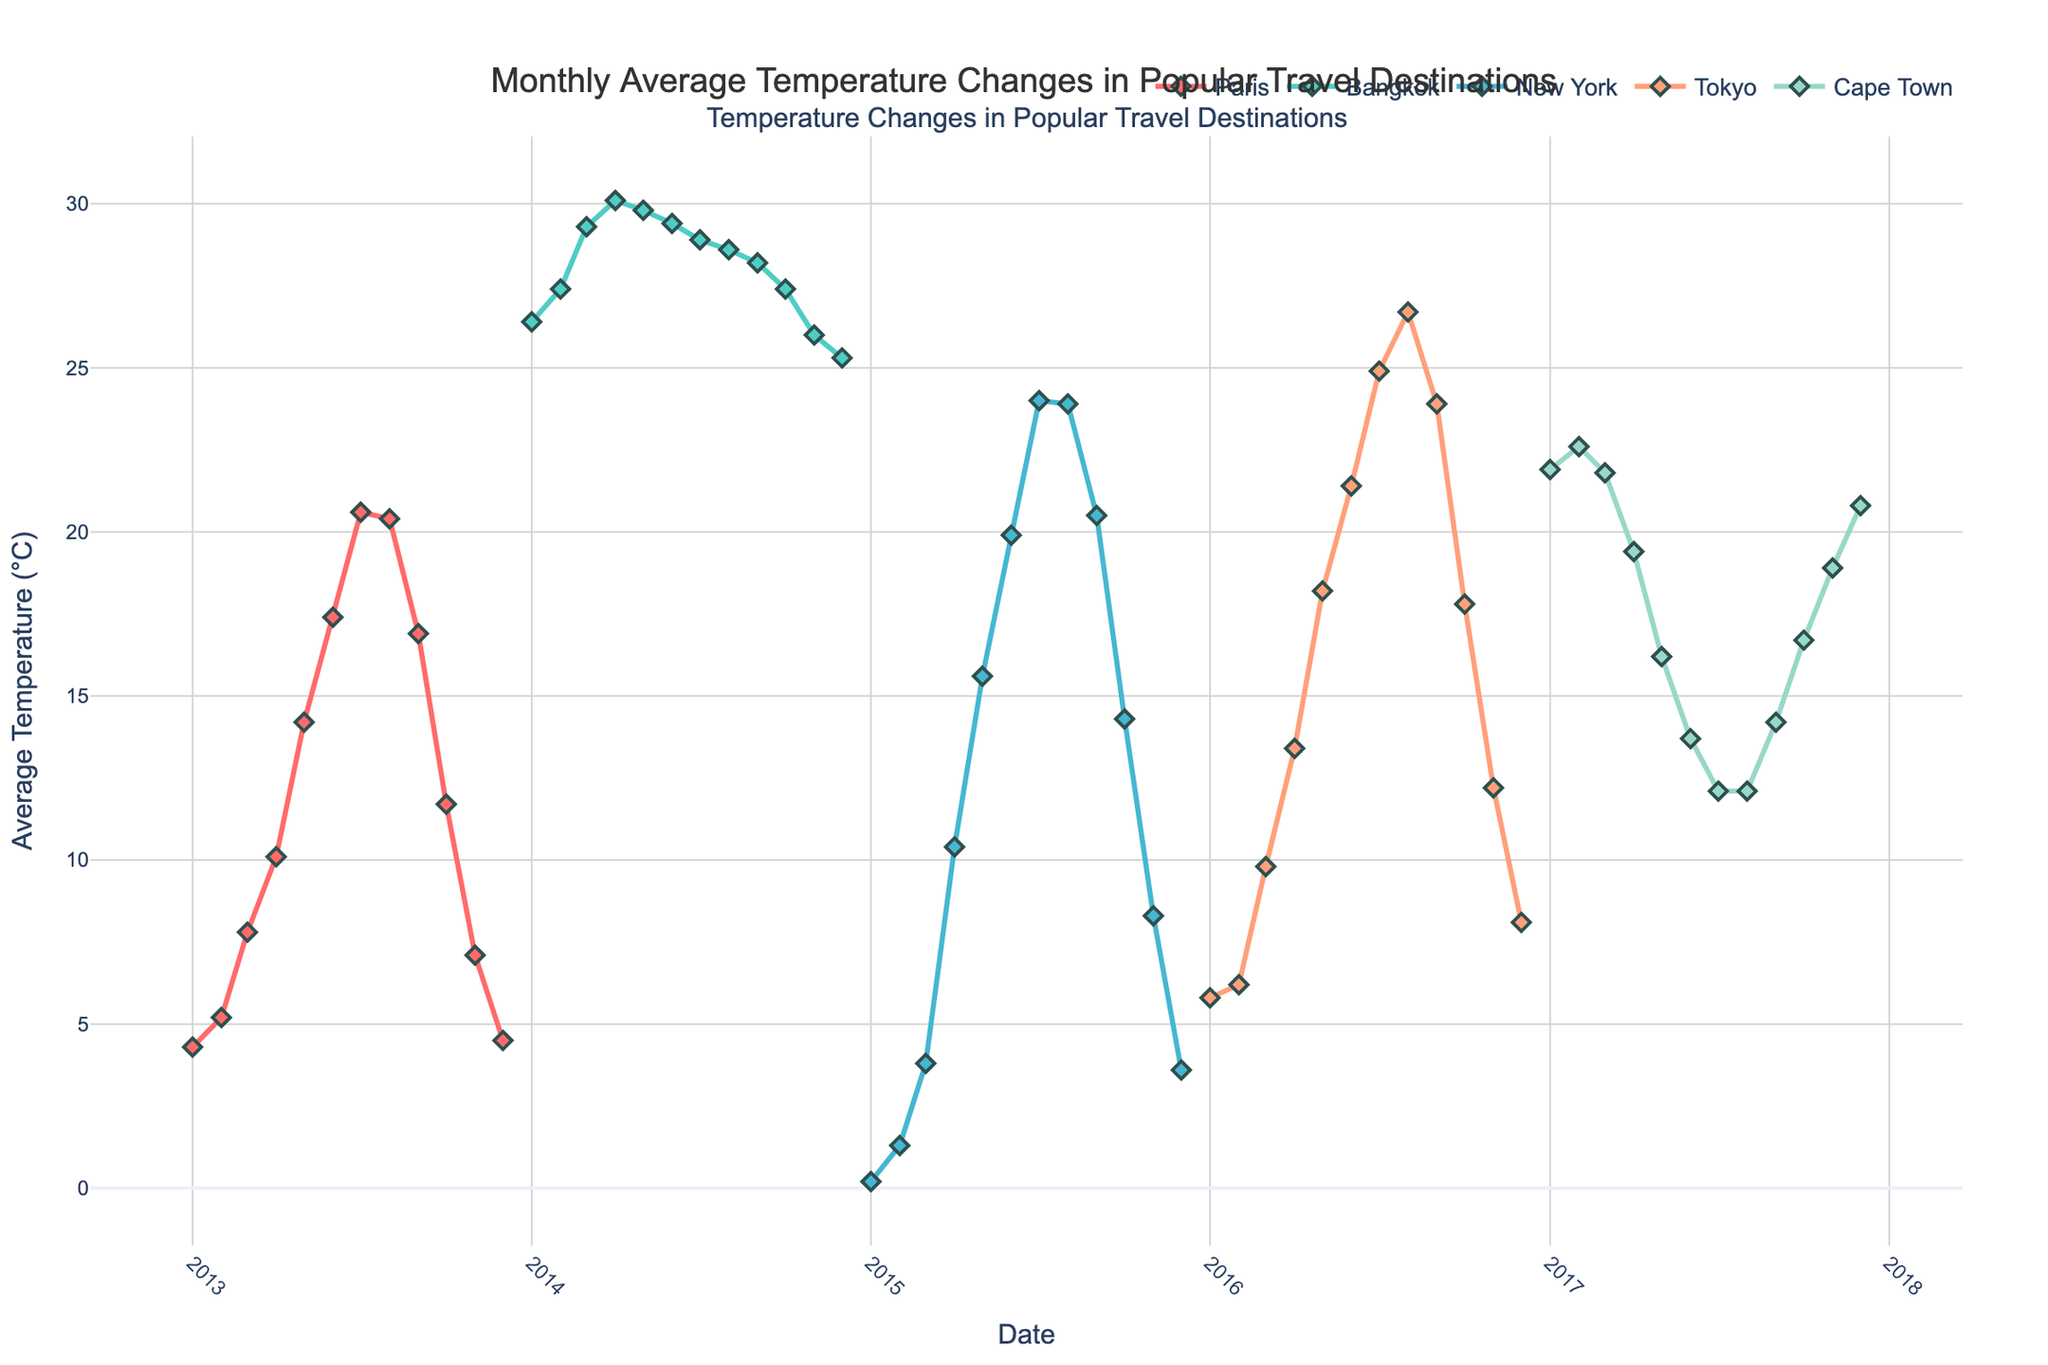What is the title of the figure? The title is displayed at the top of the figure, centered and in a larger font size compared to the axis labels.
Answer: "Monthly Average Temperature Changes in Popular Travel Destinations" Which location shows the highest temperature over the time period? Look at the lines and markers in the figure for each location and identify the one that peaks the highest on the y-axis, which represents the temperature.
Answer: Bangkok During which month and year did Paris experience its highest temperature? Trace the line corresponding to Paris and identify the point that is the highest on the y-axis. Then read the corresponding month and year from the x-axis.
Answer: July 2013 Compare the average temperatures of New York and Tokyo in July. Which city was hotter? Locate the data points for New York and Tokyo in the month of July, compare their y-values and see which one is higher.
Answer: Tokyo What is the average temperature range in Cape Town from January to December? Find the highest and lowest temperature points for Cape Town across the months and calculate the range by subtracting the lowest temperature from the highest.
Answer: 22.6 - 12.1 = 10.5°C In which month does Bangkok's temperature start to decrease after reaching its peak? Identify the peak temperature point for Bangkok and then find the subsequent month where the temperature drops.
Answer: April 2014 Among New York, Tokyo, and Cape Town, which city experiences the greatest temperature variation throughout the year? For each city, find the maximum and minimum temperature points and calculate the range. Then determine which city has the largest range.
Answer: New York How does the temperature trend in New York differ from that of Cape Town throughout the year? Examine the overall shape of the temperature lines for both cities. Note if they are increasing, decreasing, or fluctuating and contrast their behaviors.
Answer: New York trends from cold to hot, Cape Town slightly decreases from a warmer January to cooler mid-year and then rises again Which location has the smallest temperature fluctuation over the year? Calculate the temperature range for each location by finding the difference between their highest and lowest temperatures and identify the smallest one.
Answer: Bangkok 